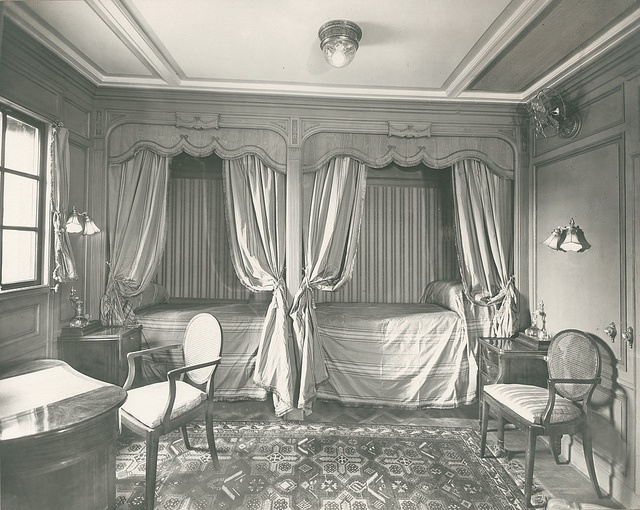Describe the objects in this image and their specific colors. I can see bed in darkgray, gray, and lightgray tones, chair in darkgray, gray, and ivory tones, and chair in darkgray, gray, and lightgray tones in this image. 